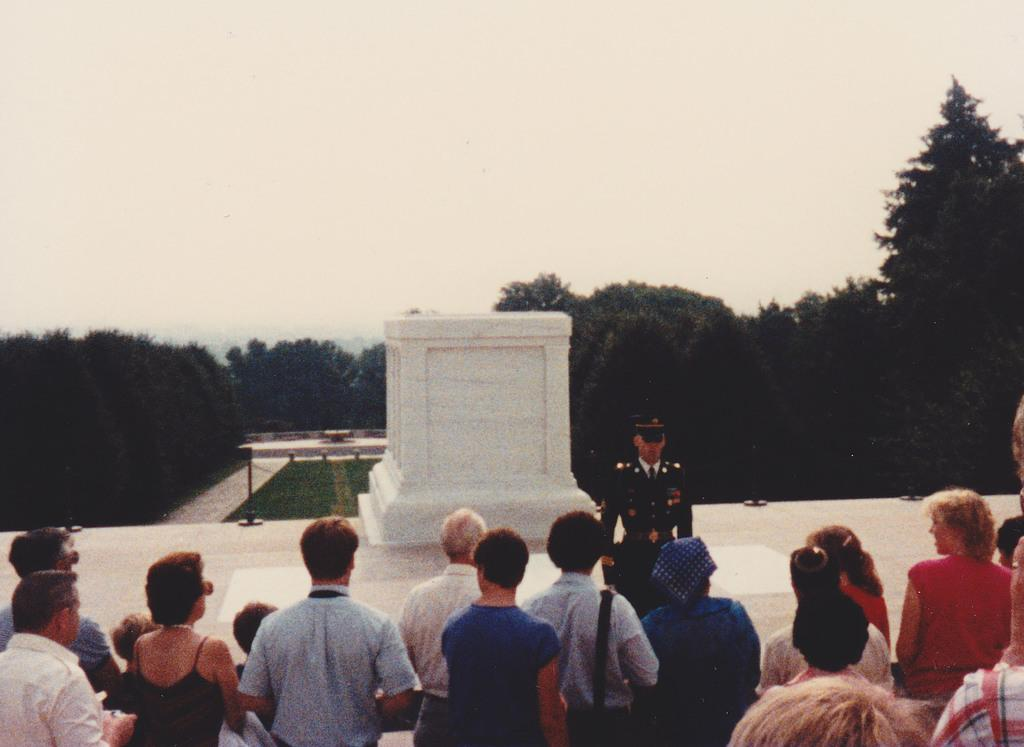Who or what can be seen in the image? There are people in the image. What objects are present in the image besides the people? There are poles and a memorial stone in the image. What type of natural environment is visible in the background of the image? There is grass, trees, and the sky visible in the background of the image. What grade does the thumb receive in the image? There is no thumb present in the image, so it cannot receive a grade. 